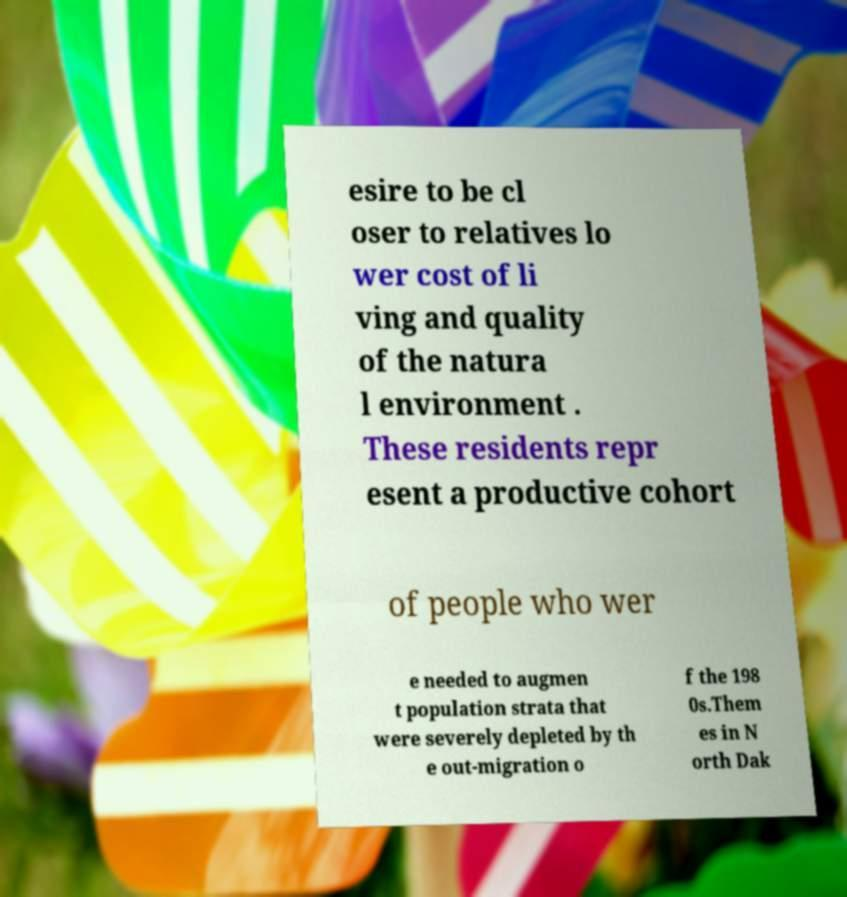For documentation purposes, I need the text within this image transcribed. Could you provide that? esire to be cl oser to relatives lo wer cost of li ving and quality of the natura l environment . These residents repr esent a productive cohort of people who wer e needed to augmen t population strata that were severely depleted by th e out-migration o f the 198 0s.Them es in N orth Dak 